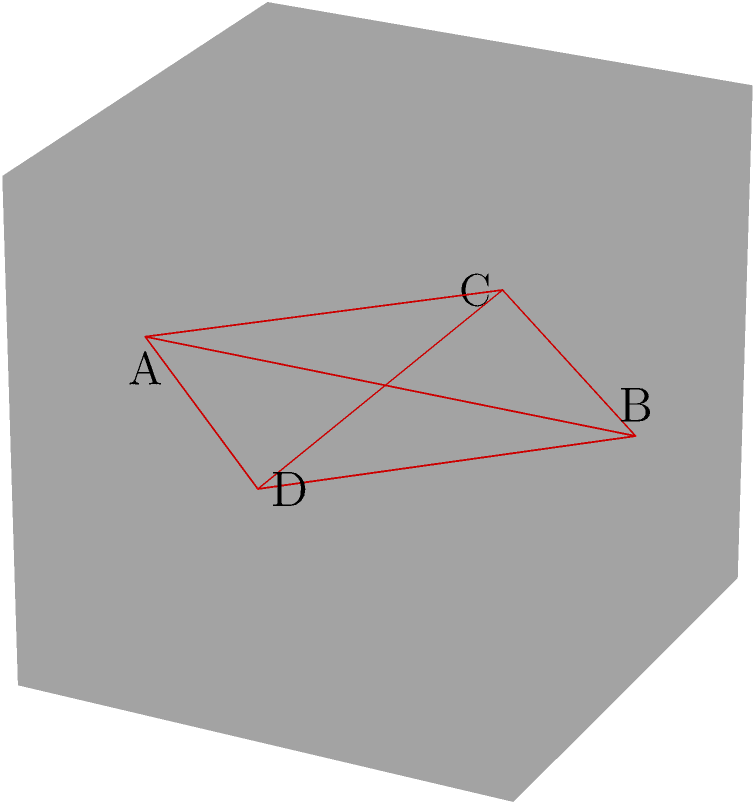As a graphic designer, you often work with 3D shapes for various projects. Consider a cube with side length $a$. A tetrahedron is formed by connecting the midpoints of four faces of the cube, as shown in the figure. What is the volume of this tetrahedron in terms of $a$? Let's approach this step-by-step:

1) First, we need to find the side length of the tetrahedron. Each vertex of the tetrahedron is at the midpoint of a cube face, so the distance between any two vertices is half the diagonal of a face of the cube.

2) The diagonal of a face is $a\sqrt{2}$ (using the Pythagorean theorem), so the side length of the tetrahedron is $\frac{a\sqrt{2}}{2}$.

3) Now we can use the formula for the volume of a tetrahedron:

   $V = \frac{a^3}{6\sqrt{2}}$

   where $a$ is the side length of the tetrahedron.

4) Substituting our side length:

   $V = \frac{(\frac{a\sqrt{2}}{2})^3}{6\sqrt{2}}$

5) Simplify:
   $V = \frac{a^3(\sqrt{2})^3}{8 \cdot 6\sqrt{2}} = \frac{a^3 \cdot 2\sqrt{2}}{48\sqrt{2}} = \frac{a^3}{24}$

Therefore, the volume of the tetrahedron is $\frac{a^3}{24}$.
Answer: $\frac{a^3}{24}$ 